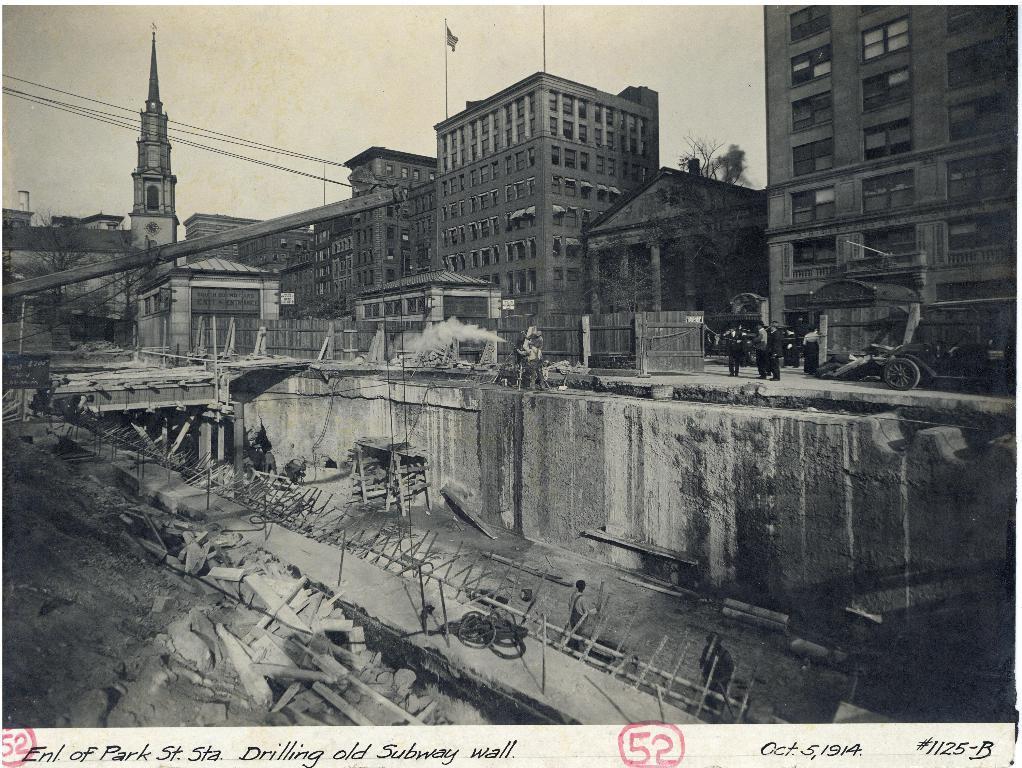Describe this image in one or two sentences. This is a black and white image where we can see people, buildings, trees, wires and a flag. At the top of the image, we can see the sky. At the bottom of the image, we can see a land and wooden bamboos. We can see some text at the bottom of the image. 